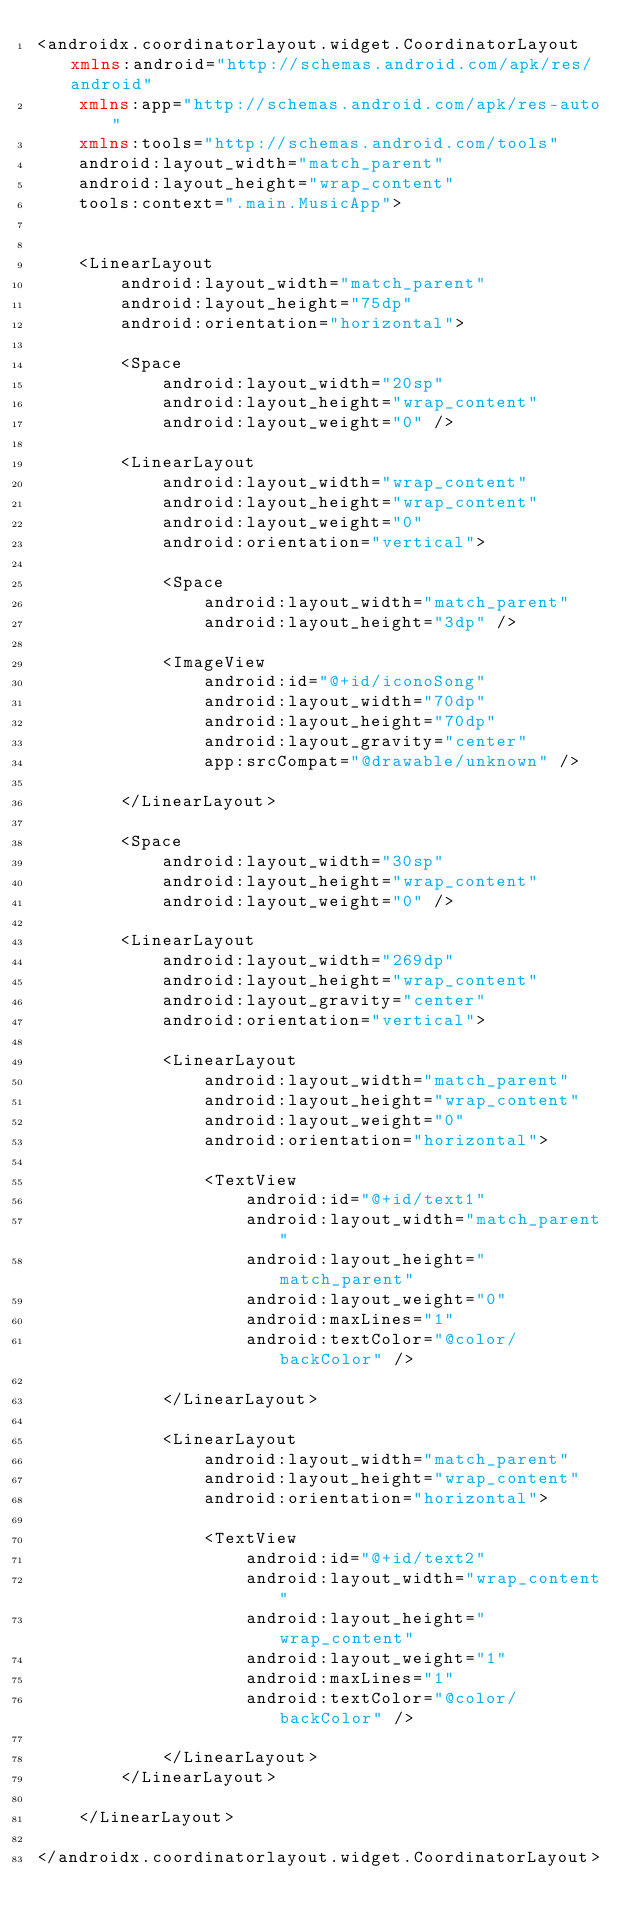Convert code to text. <code><loc_0><loc_0><loc_500><loc_500><_XML_><androidx.coordinatorlayout.widget.CoordinatorLayout xmlns:android="http://schemas.android.com/apk/res/android"
    xmlns:app="http://schemas.android.com/apk/res-auto"
    xmlns:tools="http://schemas.android.com/tools"
    android:layout_width="match_parent"
    android:layout_height="wrap_content"
    tools:context=".main.MusicApp">


    <LinearLayout
        android:layout_width="match_parent"
        android:layout_height="75dp"
        android:orientation="horizontal">

        <Space
            android:layout_width="20sp"
            android:layout_height="wrap_content"
            android:layout_weight="0" />

        <LinearLayout
            android:layout_width="wrap_content"
            android:layout_height="wrap_content"
            android:layout_weight="0"
            android:orientation="vertical">

            <Space
                android:layout_width="match_parent"
                android:layout_height="3dp" />

            <ImageView
                android:id="@+id/iconoSong"
                android:layout_width="70dp"
                android:layout_height="70dp"
                android:layout_gravity="center"
                app:srcCompat="@drawable/unknown" />

        </LinearLayout>

        <Space
            android:layout_width="30sp"
            android:layout_height="wrap_content"
            android:layout_weight="0" />

        <LinearLayout
            android:layout_width="269dp"
            android:layout_height="wrap_content"
            android:layout_gravity="center"
            android:orientation="vertical">

            <LinearLayout
                android:layout_width="match_parent"
                android:layout_height="wrap_content"
                android:layout_weight="0"
                android:orientation="horizontal">

                <TextView
                    android:id="@+id/text1"
                    android:layout_width="match_parent"
                    android:layout_height="match_parent"
                    android:layout_weight="0"
                    android:maxLines="1"
                    android:textColor="@color/backColor" />

            </LinearLayout>

            <LinearLayout
                android:layout_width="match_parent"
                android:layout_height="wrap_content"
                android:orientation="horizontal">

                <TextView
                    android:id="@+id/text2"
                    android:layout_width="wrap_content"
                    android:layout_height="wrap_content"
                    android:layout_weight="1"
                    android:maxLines="1"
                    android:textColor="@color/backColor" />

            </LinearLayout>
        </LinearLayout>

    </LinearLayout>

</androidx.coordinatorlayout.widget.CoordinatorLayout></code> 